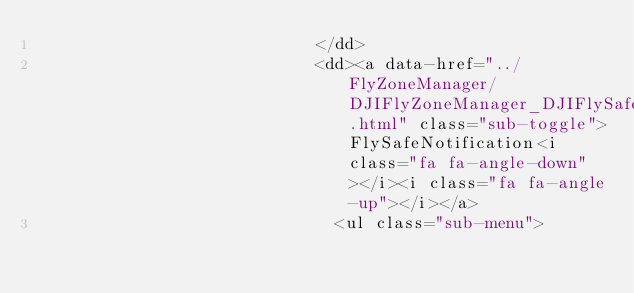<code> <loc_0><loc_0><loc_500><loc_500><_HTML_>                            </dd>
                            <dd><a data-href="../FlyZoneManager/DJIFlyZoneManager_DJIFlySafeNotification.html" class="sub-toggle">FlySafeNotification<i class="fa fa-angle-down"></i><i class="fa fa-angle-up"></i></a>
                              <ul class="sub-menu"></code> 